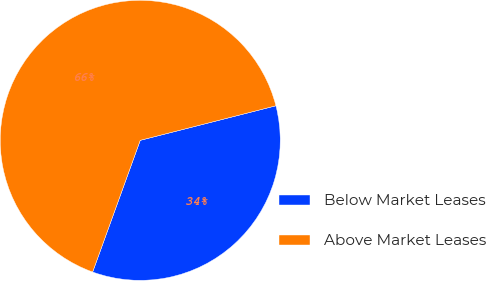Convert chart. <chart><loc_0><loc_0><loc_500><loc_500><pie_chart><fcel>Below Market Leases<fcel>Above Market Leases<nl><fcel>34.49%<fcel>65.51%<nl></chart> 